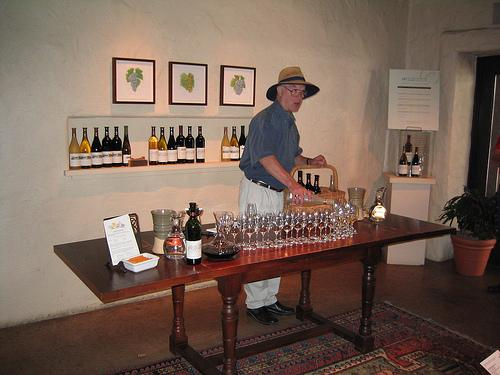How many wine glasses are there on the wooden table? There are several wine glasses on the wooden table. What type of plant is present in the image, and where is it located? A potted leafy green plant is present in the image, placed to the side of the room in an orange planter. Analyze the interaction between the man and the objects surrounding him. The man appears to be preparing for a wine tasting event, placing wine glasses on the table, and possibly pouring wine into them. He is standing behind the table, interacting with both the table and wine glasses. Count and describe the significant furnishings in the room, such as tables and shelves. There are two main furnishings in the room: a long wooden table where the wine tasting is being set up, and a small standalone shelf in the corner displaying three wine bottles on a white pedestal. What is the main sentiment or mood conveyed by the image? The image conveys a mood of sophistication, elegance, and appreciation for wine culture. What objects are displayed on the wall, and what are their characteristics? Three framed pictures of grapes are displayed on the wall, along with bottles of white and red wine on a shelf, and a rectangular white poster with wine information and pricing. Based on the image, provide an assessment of the room's overall aesthetic quality. The room has a tasteful and elegant aesthetic, with wine-related decorative elements, a neat and organized wine tasting set up, and a comfortable atmosphere created by the rug and plant in the space. Describe the scene related to wine tasting in this image. A man is setting up a wine tasting event at a long wooden table with several wine glasses, bottles of various wines, and a decanter. The wall behind him displays wine-related decor, and a rug lies beneath the table areas. Provide a detailed description of the man's appearance in the image. The man is wearing a tan hat with a black band, glasses, a blue shirt, and white pants. He appears to be old and is standing behind a table with wine glasses. What objects in the image give clues to the theme or purpose of the scene? The wine glasses, bottles of wine, decanter, and related wall decorations suggest that the theme and purpose of the scene revolve around wine tasting and appreciation for wine heritage. What type of hat is the man wearing? A tan hat with a black band. What task is the man performing? He is pouring wine. Which item in the image is used to carry wine bottles? A tan wicker basket. Is there a plant in the room? If so, describe it. Yes, there is a potted plant in a brown plastic container. What color is the man's shirt? Blue. What does the man's hat look like? It is a tan hat with a black band. Does the image feature any art or decorations on the walls? Yes, there are three framed pictures of grapes and a rectangular white poster. Is the wine being poured into a glass or a decanter? Into a glass. What is on top of the table? Several wine glasses and a bottle of wine and decanter. How many wine bottles are on the white pedestal? Three. Briefly describe the main activity in the scene. The man is setting up a wine tasting. What's the color of the plant container? Brown. Describe the potted plant. It is a leafy green plant in a brown plastic container. Which of these is on the floor: a rug, a table, or a chair? A rug. Write a descriptive caption for the scene. An old man in a tan hat and glasses pours wine at a tasting event with several wine glasses and wine bottles displayed on a table and wall shelf. A decorative rug and potted plant add to the cozy ambiance. What type of glasses are on the man's face? Eyeglasses. List the primary colors seen in the rug. Multicolored. Identify the arrangements made for the wine tasting. A long table with wine glasses, wine bottles on a wall shelf and a white pedestal, and a man pouring wine. Where are the wine bottles located? On a shelf on the wall. What items are stored in the white container? Pencils. 